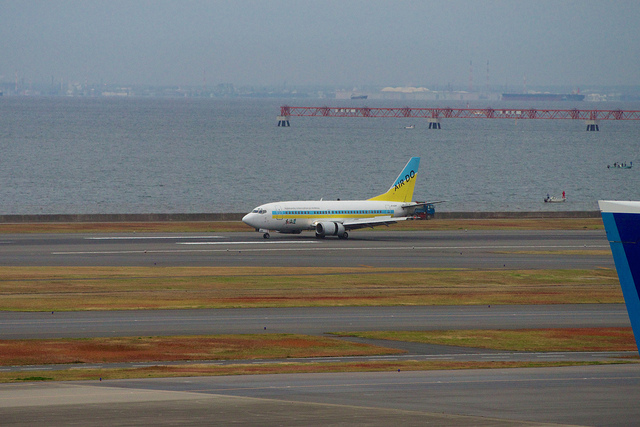<image>What is the name of the aircraft's manufacturer? The name of the aircraft's manufacturer is unknown. It could be 'arbo' or 'boeing'. What is the name of the aircraft's manufacturer? I am not sure what is the name of the aircraft's manufacturer. It can be 'arbo', 'boeing', 'southwest' or 'airbo'. 